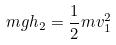<formula> <loc_0><loc_0><loc_500><loc_500>m g h _ { 2 } = \frac { 1 } { 2 } m v _ { 1 } ^ { 2 }</formula> 